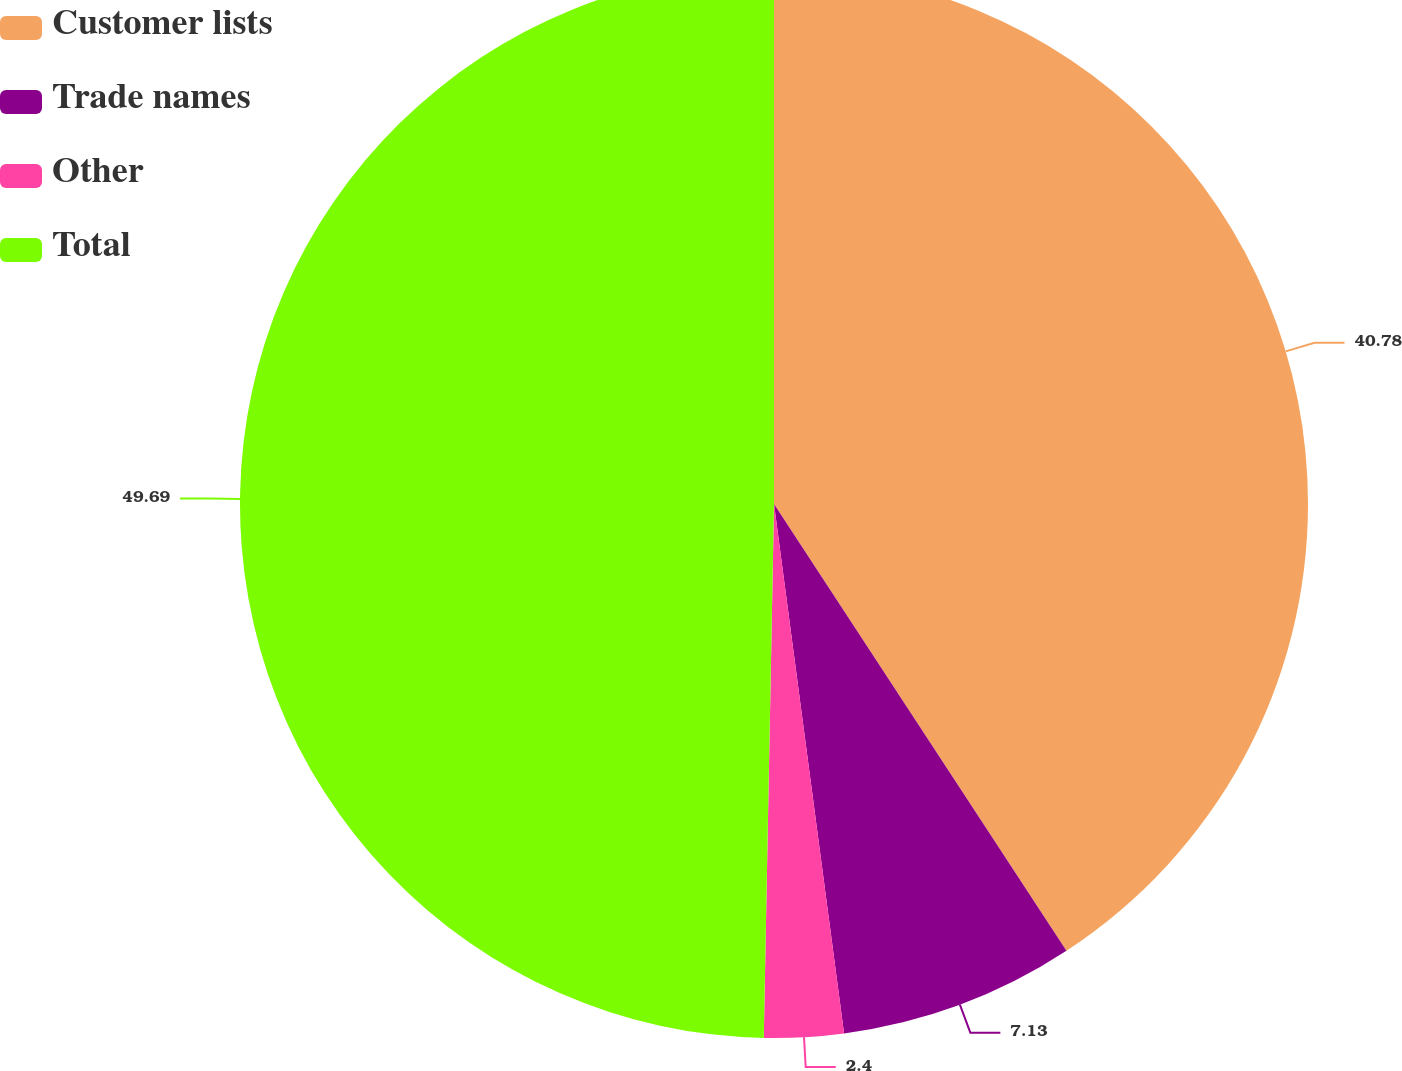<chart> <loc_0><loc_0><loc_500><loc_500><pie_chart><fcel>Customer lists<fcel>Trade names<fcel>Other<fcel>Total<nl><fcel>40.78%<fcel>7.13%<fcel>2.4%<fcel>49.7%<nl></chart> 